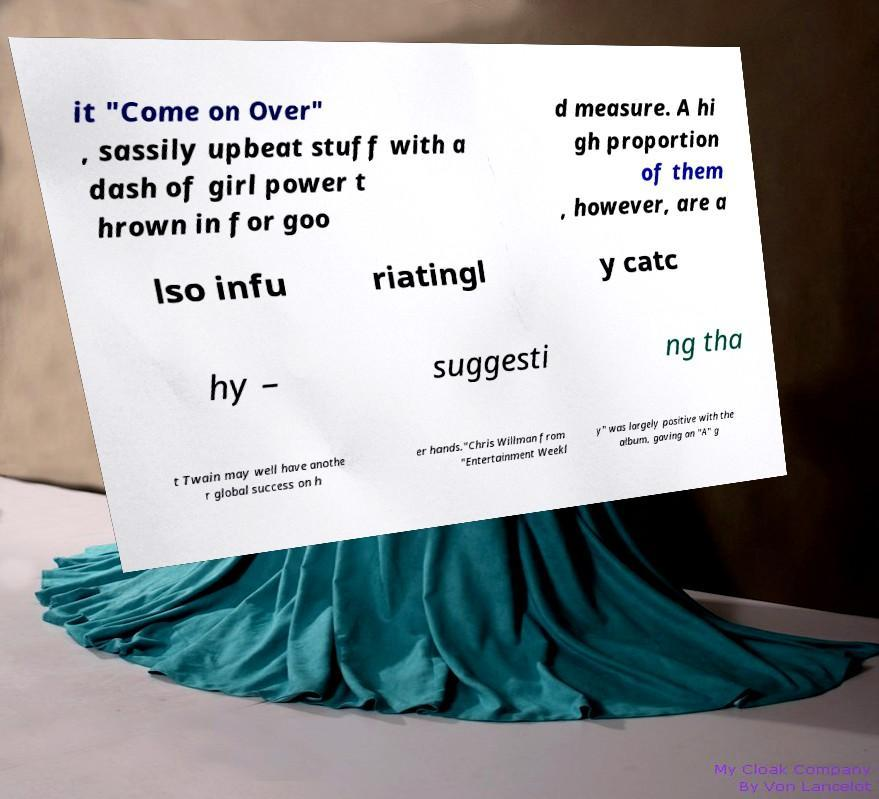What messages or text are displayed in this image? I need them in a readable, typed format. it "Come on Over" , sassily upbeat stuff with a dash of girl power t hrown in for goo d measure. A hi gh proportion of them , however, are a lso infu riatingl y catc hy – suggesti ng tha t Twain may well have anothe r global success on h er hands."Chris Willman from "Entertainment Weekl y" was largely positive with the album, gaving an "A" g 